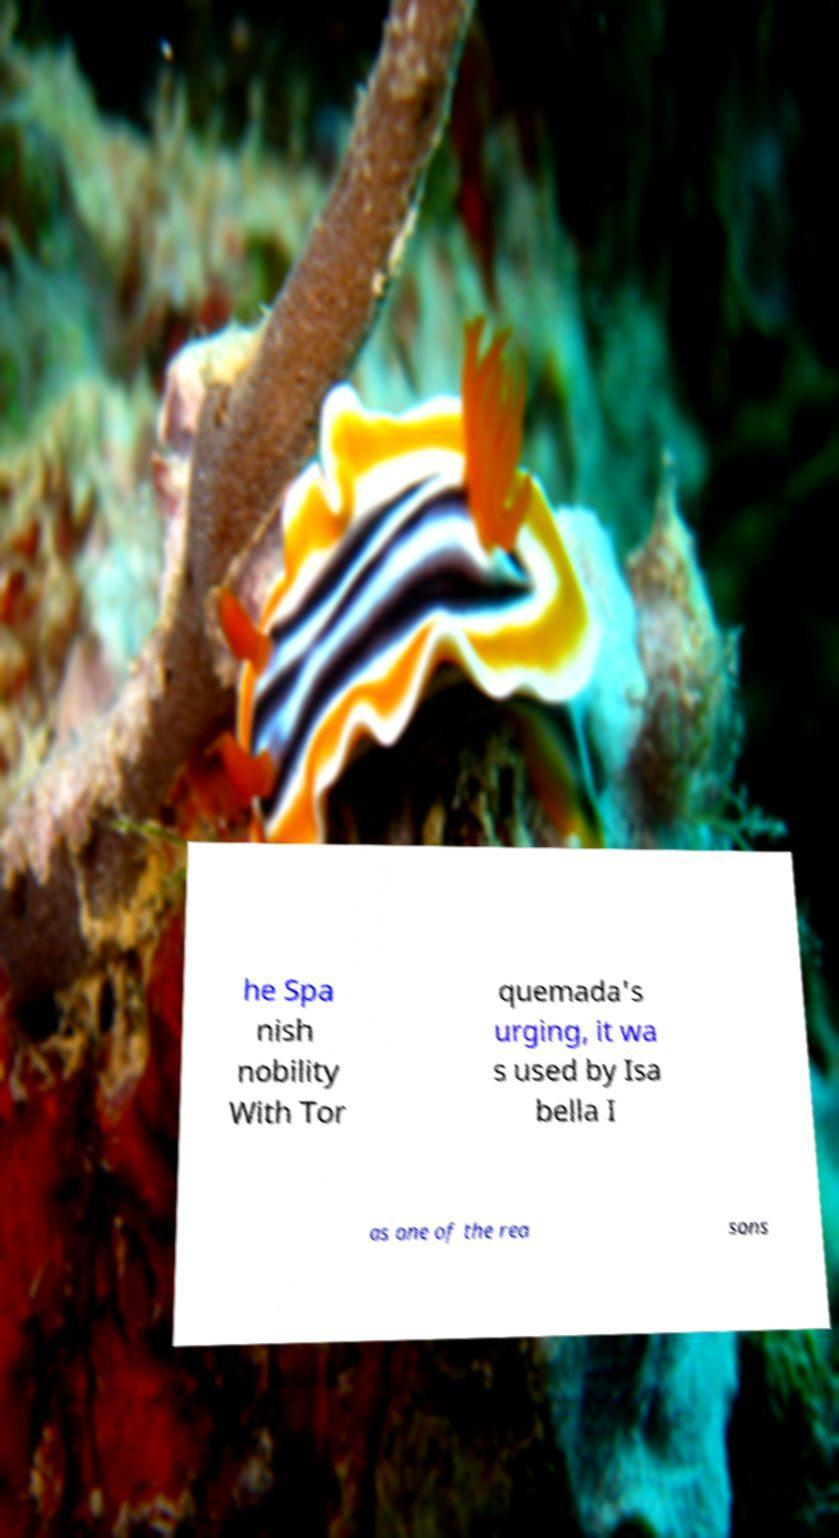There's text embedded in this image that I need extracted. Can you transcribe it verbatim? he Spa nish nobility With Tor quemada's urging, it wa s used by Isa bella I as one of the rea sons 